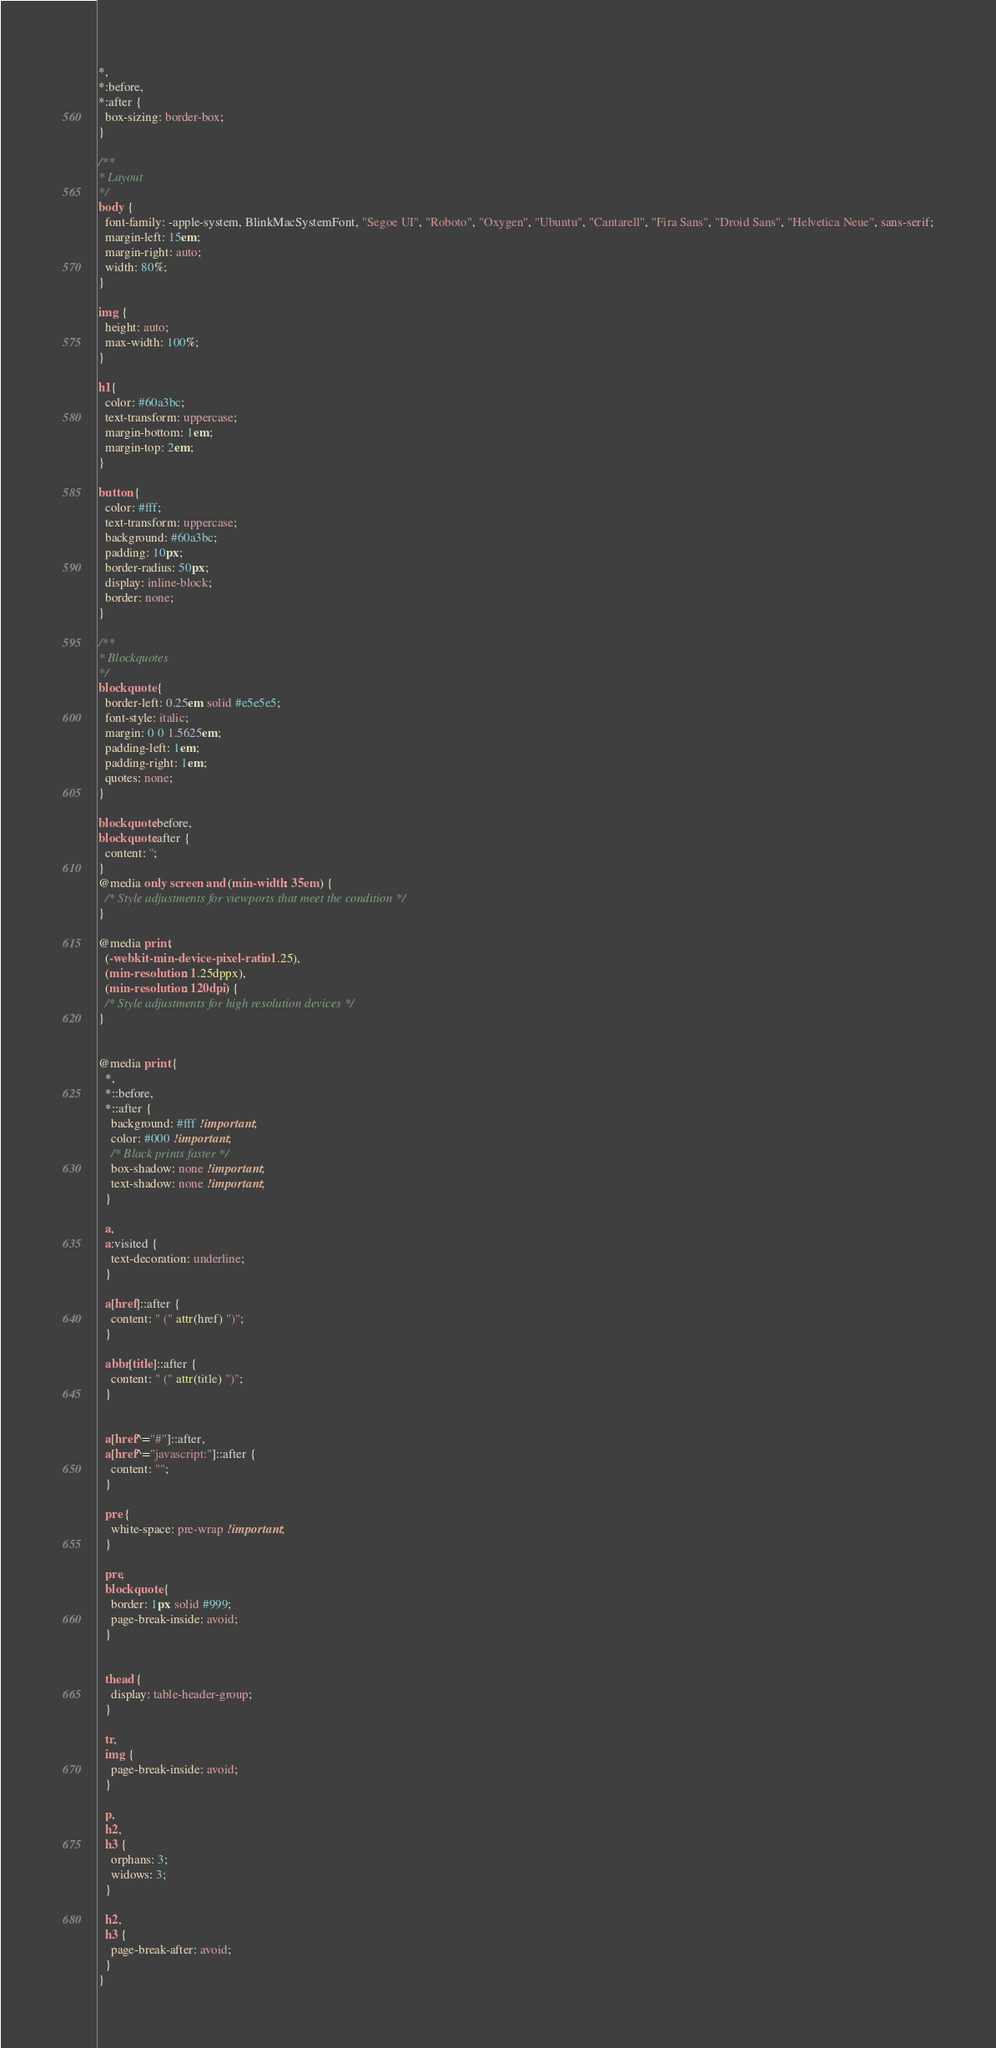<code> <loc_0><loc_0><loc_500><loc_500><_CSS_>*,
*:before,
*:after {
  box-sizing: border-box;
}

/**
* Layout
*/
body {
  font-family: -apple-system, BlinkMacSystemFont, "Segoe UI", "Roboto", "Oxygen", "Ubuntu", "Cantarell", "Fira Sans", "Droid Sans", "Helvetica Neue", sans-serif;
  margin-left: 15em;
  margin-right: auto;
  width: 80%;
}

img {
  height: auto;
  max-width: 100%;
}

h1{
  color: #60a3bc;
  text-transform: uppercase;
  margin-bottom: 1em;
  margin-top: 2em;
}

button {
  color: #fff;
  text-transform: uppercase;
  background: #60a3bc;
  padding: 10px;
  border-radius: 50px;
  display: inline-block;
  border: none;
}

/**
* Blockquotes
*/
blockquote {
  border-left: 0.25em solid #e5e5e5;
  font-style: italic;
  margin: 0 0 1.5625em;
  padding-left: 1em;
  padding-right: 1em;
  quotes: none;
}

blockquote:before,
blockquote:after {
  content: '';
}
@media only screen and (min-width: 35em) {
  /* Style adjustments for viewports that meet the condition */
}

@media print,
  (-webkit-min-device-pixel-ratio: 1.25),
  (min-resolution: 1.25dppx),
  (min-resolution: 120dpi) {
  /* Style adjustments for high resolution devices */
}


@media print {
  *,
  *::before,
  *::after {
    background: #fff !important;
    color: #000 !important;
    /* Black prints faster */
    box-shadow: none !important;
    text-shadow: none !important;
  }

  a,
  a:visited {
    text-decoration: underline;
  }

  a[href]::after {
    content: " (" attr(href) ")";
  }

  abbr[title]::after {
    content: " (" attr(title) ")";
  }


  a[href^="#"]::after,
  a[href^="javascript:"]::after {
    content: "";
  }

  pre {
    white-space: pre-wrap !important;
  }

  pre,
  blockquote {
    border: 1px solid #999;
    page-break-inside: avoid;
  }


  thead {
    display: table-header-group;
  }

  tr,
  img {
    page-break-inside: avoid;
  }

  p,
  h2,
  h3 {
    orphans: 3;
    widows: 3;
  }

  h2,
  h3 {
    page-break-after: avoid;
  }
}

</code> 